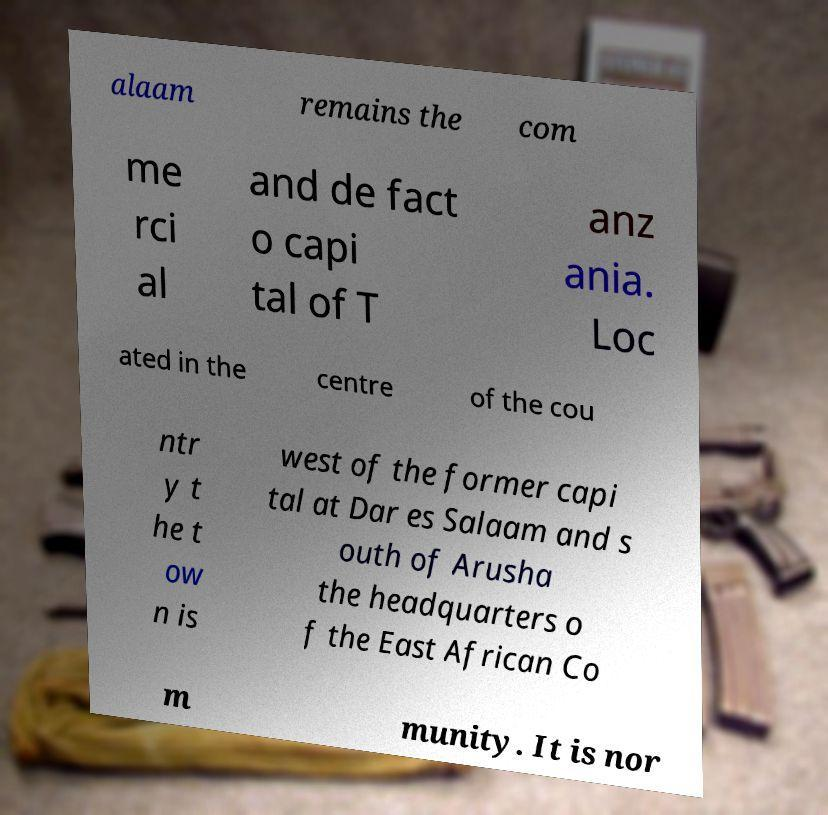What messages or text are displayed in this image? I need them in a readable, typed format. alaam remains the com me rci al and de fact o capi tal of T anz ania. Loc ated in the centre of the cou ntr y t he t ow n is west of the former capi tal at Dar es Salaam and s outh of Arusha the headquarters o f the East African Co m munity. It is nor 